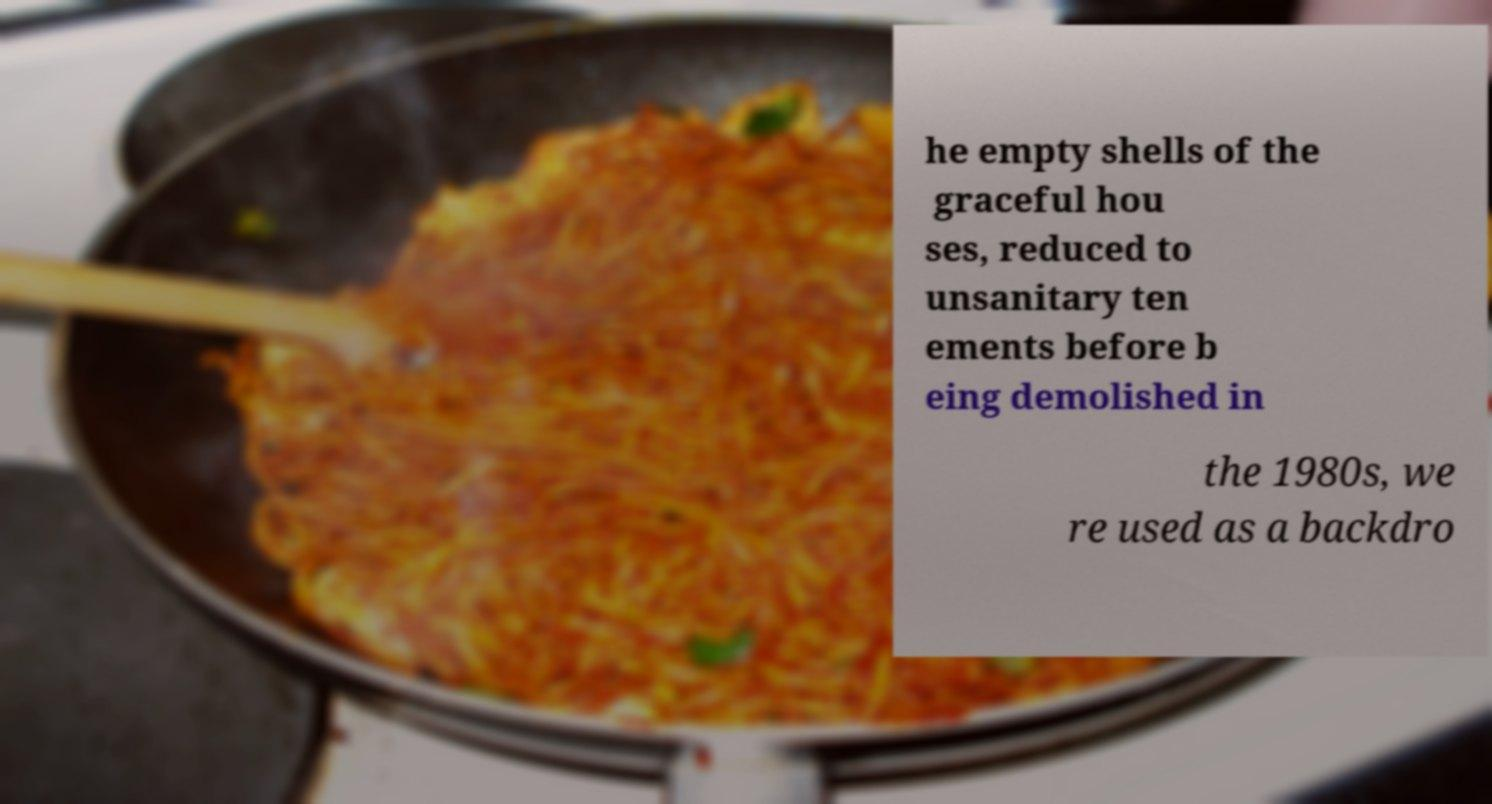Can you read and provide the text displayed in the image?This photo seems to have some interesting text. Can you extract and type it out for me? he empty shells of the graceful hou ses, reduced to unsanitary ten ements before b eing demolished in the 1980s, we re used as a backdro 